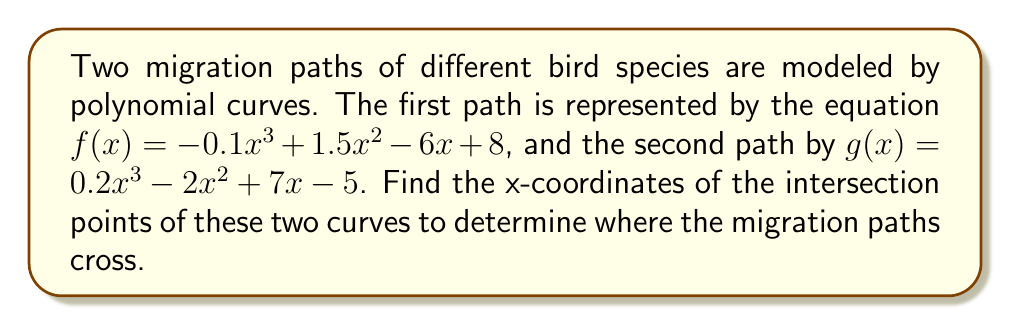Solve this math problem. To find the intersection points of the two polynomial curves, we need to solve the equation $f(x) = g(x)$. Let's follow these steps:

1) Set up the equation:
   $-0.1x^3 + 1.5x^2 - 6x + 8 = 0.2x^3 - 2x^2 + 7x - 5$

2) Subtract the right side from both sides:
   $-0.1x^3 + 1.5x^2 - 6x + 8 - (0.2x^3 - 2x^2 + 7x - 5) = 0$

3) Simplify:
   $-0.3x^3 + 3.5x^2 - 13x + 13 = 0$

4) Multiply all terms by -10 to eliminate fractions:
   $3x^3 - 35x^2 + 130x - 130 = 0$

5) This is a cubic equation. It can be solved using various methods such as the cubic formula, factoring, or numerical methods. In this case, we can factor out $(x - 5)$:

   $3x^3 - 35x^2 + 130x - 130 = (x - 5)(3x^2 - 20x + 26) = 0$

6) Now we can solve $(x - 5) = 0$ and $3x^2 - 20x + 26 = 0$

   From $(x - 5) = 0$, we get $x = 5$

   For $3x^2 - 20x + 26 = 0$, we can use the quadratic formula:
   $x = \frac{-b \pm \sqrt{b^2 - 4ac}}{2a}$

   Where $a = 3$, $b = -20$, and $c = 26$

   $x = \frac{20 \pm \sqrt{400 - 312}}{6} = \frac{20 \pm \sqrt{88}}{6} = \frac{20 \pm 2\sqrt{22}}{6}$

7) Simplify:
   $x = \frac{10 \pm \sqrt{22}}{3}$

Therefore, the x-coordinates of the intersection points are $x = 5$, $x = \frac{10 + \sqrt{22}}{3}$, and $x = \frac{10 - \sqrt{22}}{3}$.
Answer: The x-coordinates of the intersection points are $x = 5$, $x = \frac{10 + \sqrt{22}}{3}$, and $x = \frac{10 - \sqrt{22}}{3}$. 